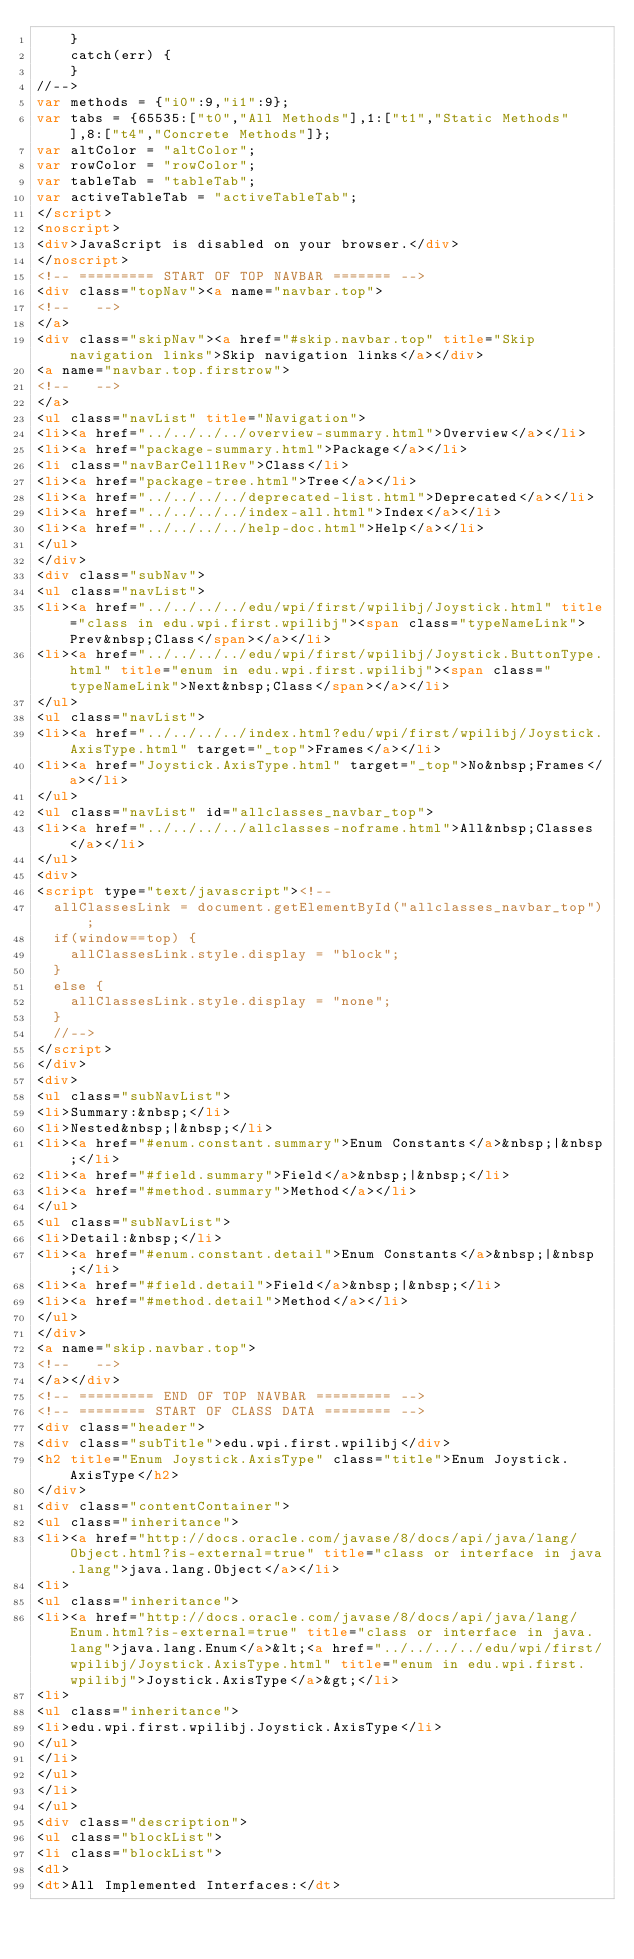<code> <loc_0><loc_0><loc_500><loc_500><_HTML_>    }
    catch(err) {
    }
//-->
var methods = {"i0":9,"i1":9};
var tabs = {65535:["t0","All Methods"],1:["t1","Static Methods"],8:["t4","Concrete Methods"]};
var altColor = "altColor";
var rowColor = "rowColor";
var tableTab = "tableTab";
var activeTableTab = "activeTableTab";
</script>
<noscript>
<div>JavaScript is disabled on your browser.</div>
</noscript>
<!-- ========= START OF TOP NAVBAR ======= -->
<div class="topNav"><a name="navbar.top">
<!--   -->
</a>
<div class="skipNav"><a href="#skip.navbar.top" title="Skip navigation links">Skip navigation links</a></div>
<a name="navbar.top.firstrow">
<!--   -->
</a>
<ul class="navList" title="Navigation">
<li><a href="../../../../overview-summary.html">Overview</a></li>
<li><a href="package-summary.html">Package</a></li>
<li class="navBarCell1Rev">Class</li>
<li><a href="package-tree.html">Tree</a></li>
<li><a href="../../../../deprecated-list.html">Deprecated</a></li>
<li><a href="../../../../index-all.html">Index</a></li>
<li><a href="../../../../help-doc.html">Help</a></li>
</ul>
</div>
<div class="subNav">
<ul class="navList">
<li><a href="../../../../edu/wpi/first/wpilibj/Joystick.html" title="class in edu.wpi.first.wpilibj"><span class="typeNameLink">Prev&nbsp;Class</span></a></li>
<li><a href="../../../../edu/wpi/first/wpilibj/Joystick.ButtonType.html" title="enum in edu.wpi.first.wpilibj"><span class="typeNameLink">Next&nbsp;Class</span></a></li>
</ul>
<ul class="navList">
<li><a href="../../../../index.html?edu/wpi/first/wpilibj/Joystick.AxisType.html" target="_top">Frames</a></li>
<li><a href="Joystick.AxisType.html" target="_top">No&nbsp;Frames</a></li>
</ul>
<ul class="navList" id="allclasses_navbar_top">
<li><a href="../../../../allclasses-noframe.html">All&nbsp;Classes</a></li>
</ul>
<div>
<script type="text/javascript"><!--
  allClassesLink = document.getElementById("allclasses_navbar_top");
  if(window==top) {
    allClassesLink.style.display = "block";
  }
  else {
    allClassesLink.style.display = "none";
  }
  //-->
</script>
</div>
<div>
<ul class="subNavList">
<li>Summary:&nbsp;</li>
<li>Nested&nbsp;|&nbsp;</li>
<li><a href="#enum.constant.summary">Enum Constants</a>&nbsp;|&nbsp;</li>
<li><a href="#field.summary">Field</a>&nbsp;|&nbsp;</li>
<li><a href="#method.summary">Method</a></li>
</ul>
<ul class="subNavList">
<li>Detail:&nbsp;</li>
<li><a href="#enum.constant.detail">Enum Constants</a>&nbsp;|&nbsp;</li>
<li><a href="#field.detail">Field</a>&nbsp;|&nbsp;</li>
<li><a href="#method.detail">Method</a></li>
</ul>
</div>
<a name="skip.navbar.top">
<!--   -->
</a></div>
<!-- ========= END OF TOP NAVBAR ========= -->
<!-- ======== START OF CLASS DATA ======== -->
<div class="header">
<div class="subTitle">edu.wpi.first.wpilibj</div>
<h2 title="Enum Joystick.AxisType" class="title">Enum Joystick.AxisType</h2>
</div>
<div class="contentContainer">
<ul class="inheritance">
<li><a href="http://docs.oracle.com/javase/8/docs/api/java/lang/Object.html?is-external=true" title="class or interface in java.lang">java.lang.Object</a></li>
<li>
<ul class="inheritance">
<li><a href="http://docs.oracle.com/javase/8/docs/api/java/lang/Enum.html?is-external=true" title="class or interface in java.lang">java.lang.Enum</a>&lt;<a href="../../../../edu/wpi/first/wpilibj/Joystick.AxisType.html" title="enum in edu.wpi.first.wpilibj">Joystick.AxisType</a>&gt;</li>
<li>
<ul class="inheritance">
<li>edu.wpi.first.wpilibj.Joystick.AxisType</li>
</ul>
</li>
</ul>
</li>
</ul>
<div class="description">
<ul class="blockList">
<li class="blockList">
<dl>
<dt>All Implemented Interfaces:</dt></code> 